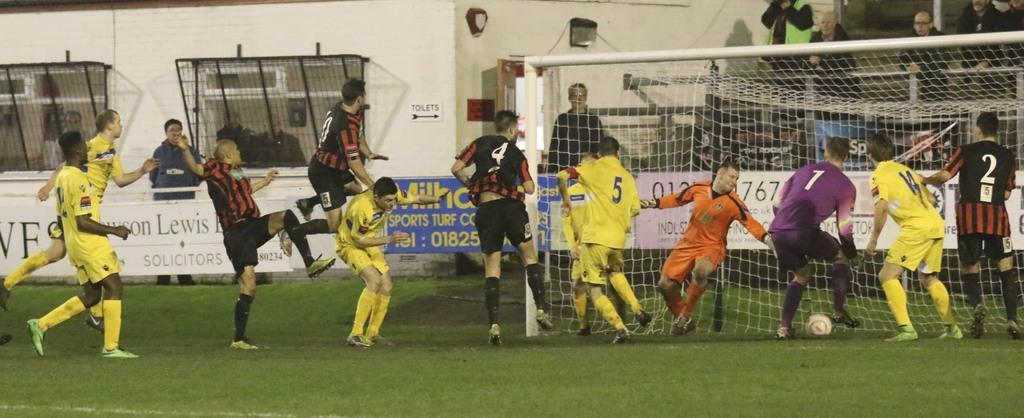<image>
Offer a succinct explanation of the picture presented. Soccer players playing soccer in fron of a sign for sports turf 